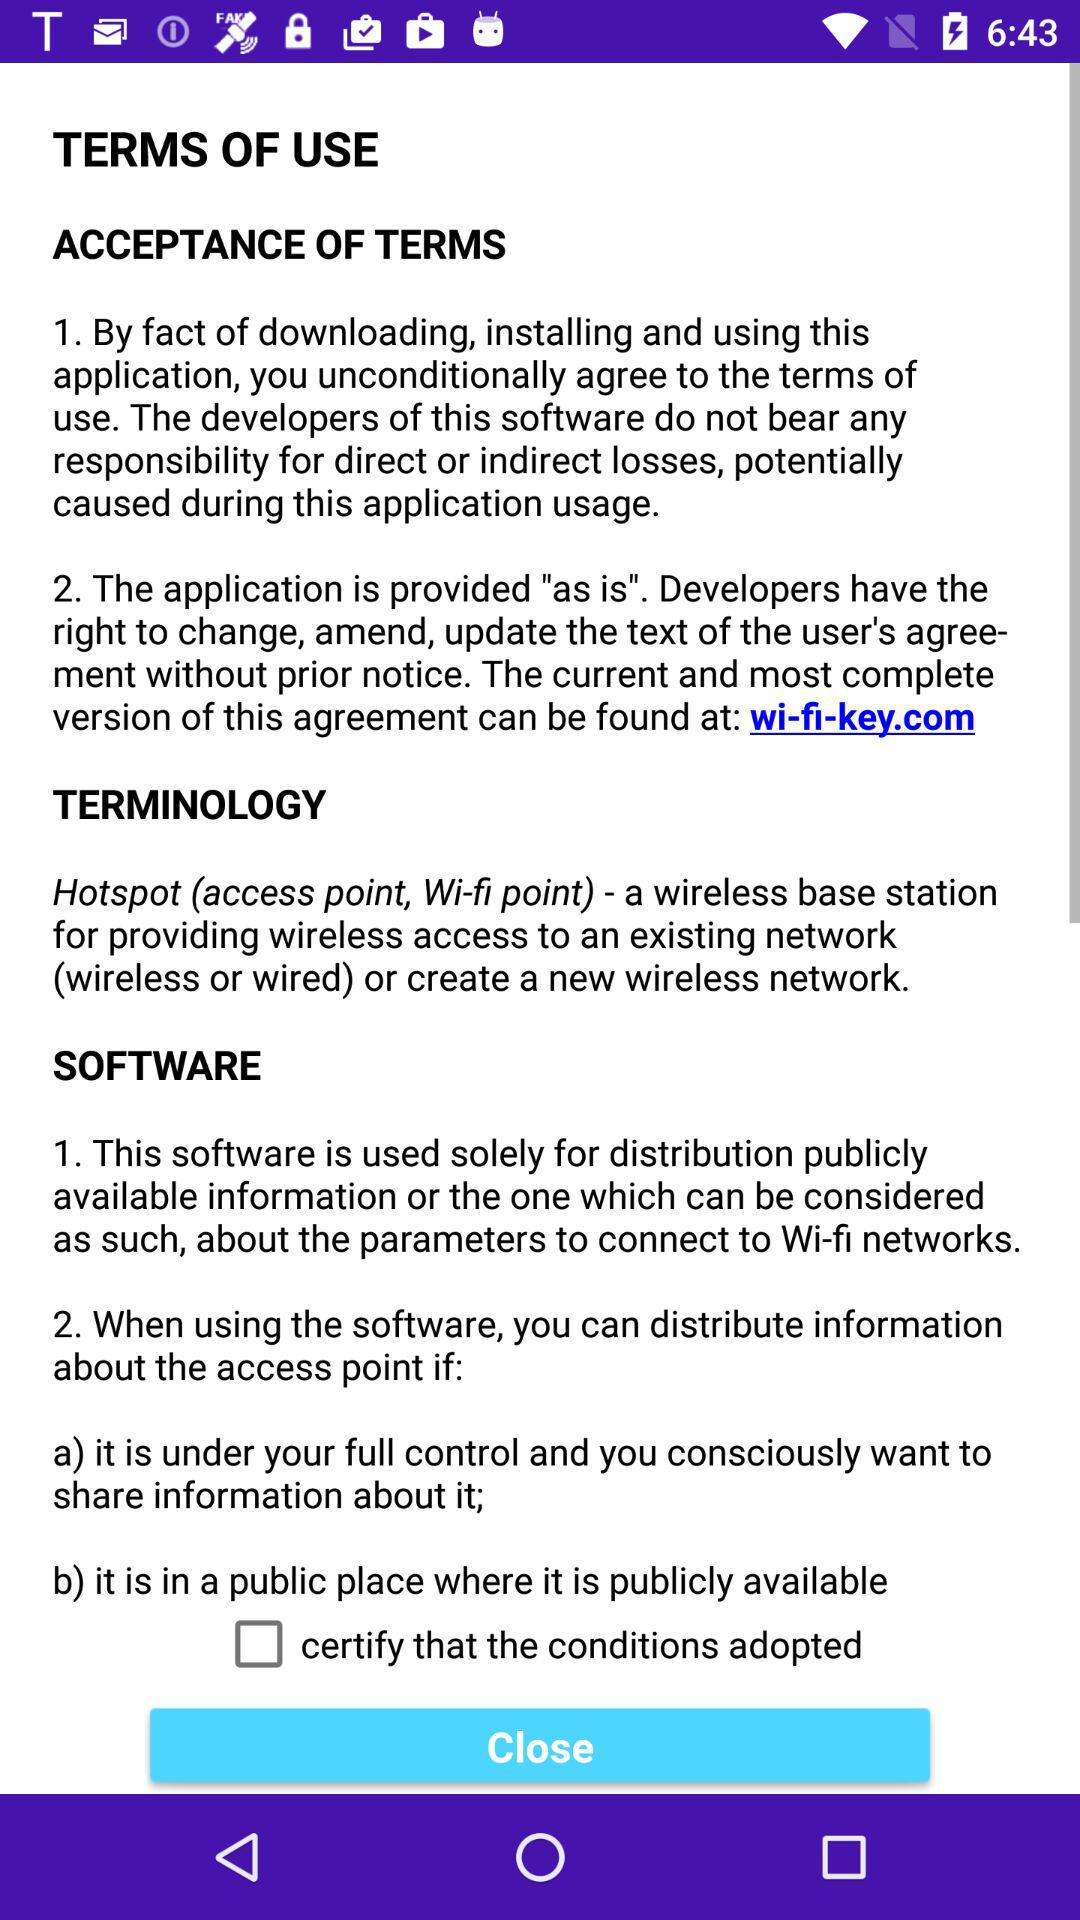What is software? Software is "1. This software is used solely for distribution publicly available information or the one which can be considered as such, about the parameters to connect to Wi-fi networks." and "2. When using the software, you can distribute information about the access point if: a) it is under your full control and you consciously want to share information about it; b) it is in a public place where it is publicly available". 